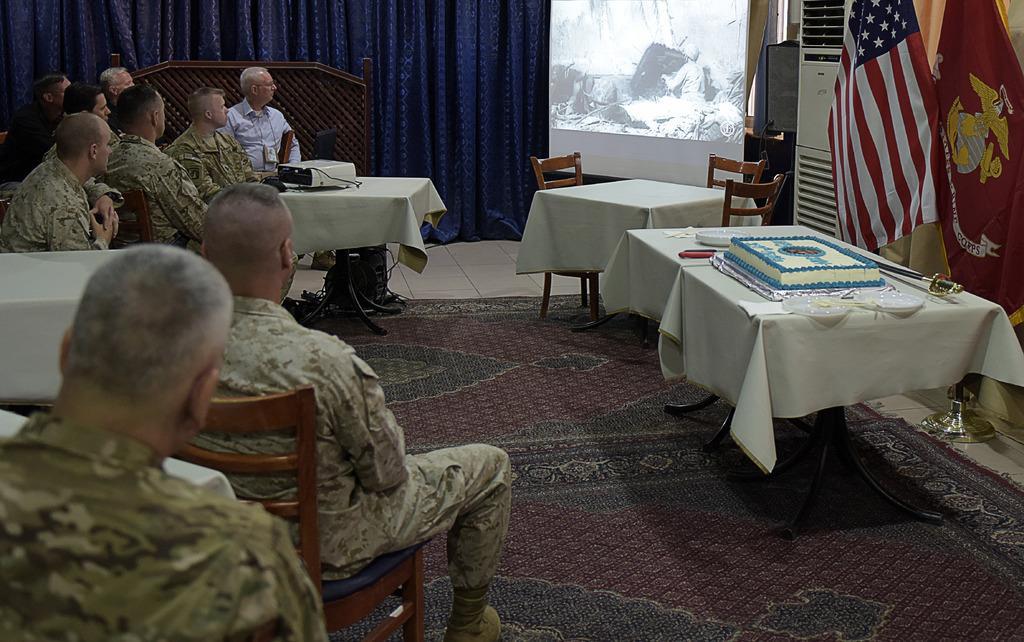How would you summarize this image in a sentence or two? In the image we can see there are men who are sitting on chair and on table there is a projector and behind there are curtains which are in blue colour. On table there is a cake a knife sword and behind there is a flags and an air conditioner cooler. 